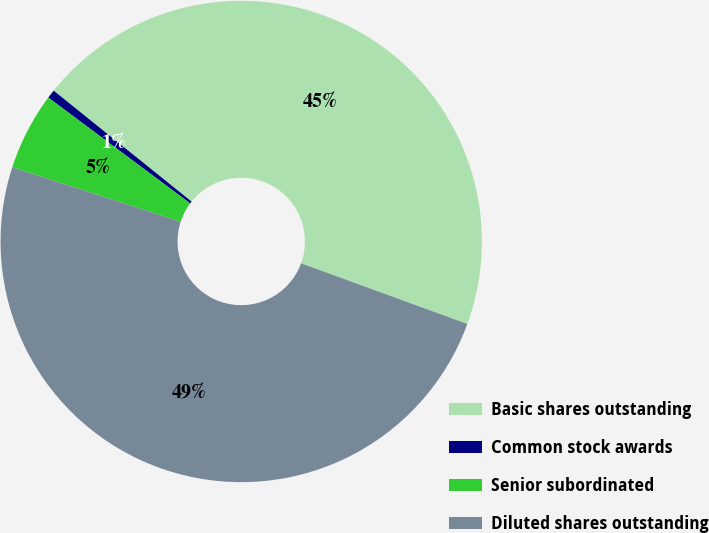<chart> <loc_0><loc_0><loc_500><loc_500><pie_chart><fcel>Basic shares outstanding<fcel>Common stock awards<fcel>Senior subordinated<fcel>Diluted shares outstanding<nl><fcel>44.79%<fcel>0.58%<fcel>5.21%<fcel>49.42%<nl></chart> 